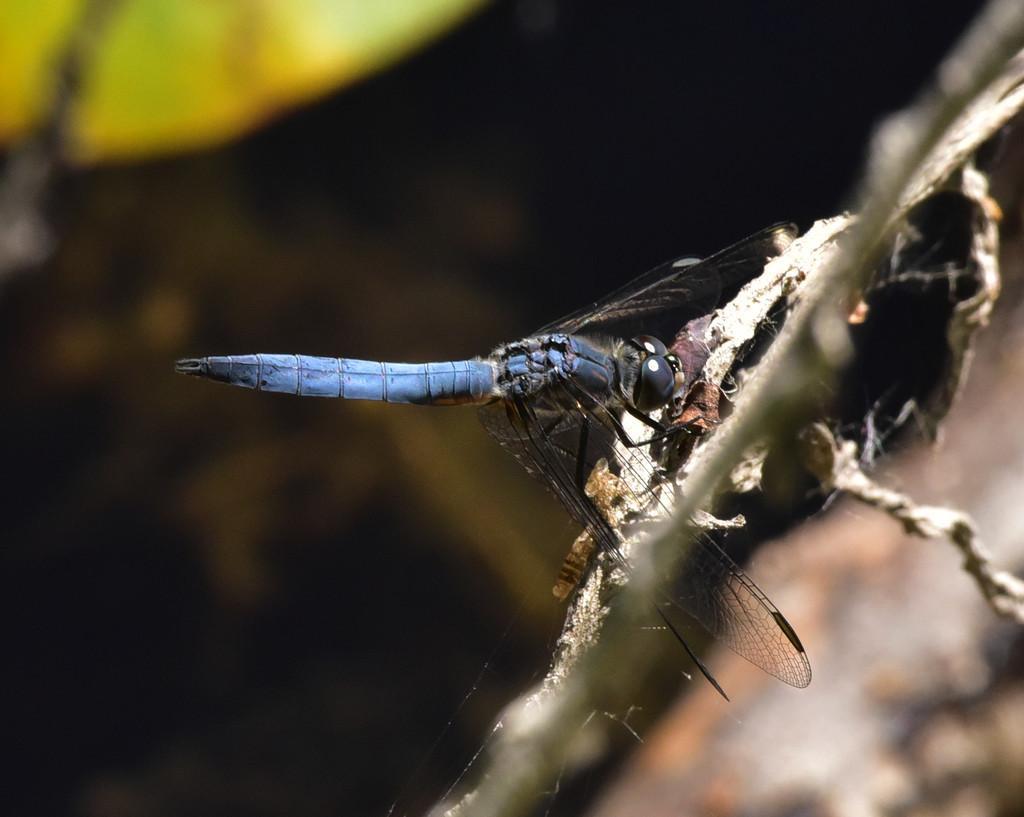In one or two sentences, can you explain what this image depicts? In this picture there is a dragonfly on the plant. At the back the image is blurry and the dragonfly is in blue and black color. 